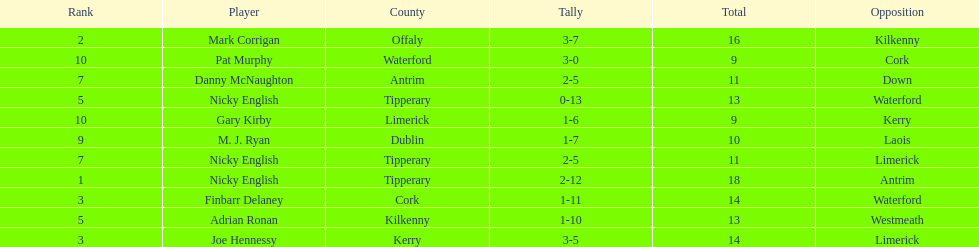What was the average of the totals of nicky english and mark corrigan? 17. 